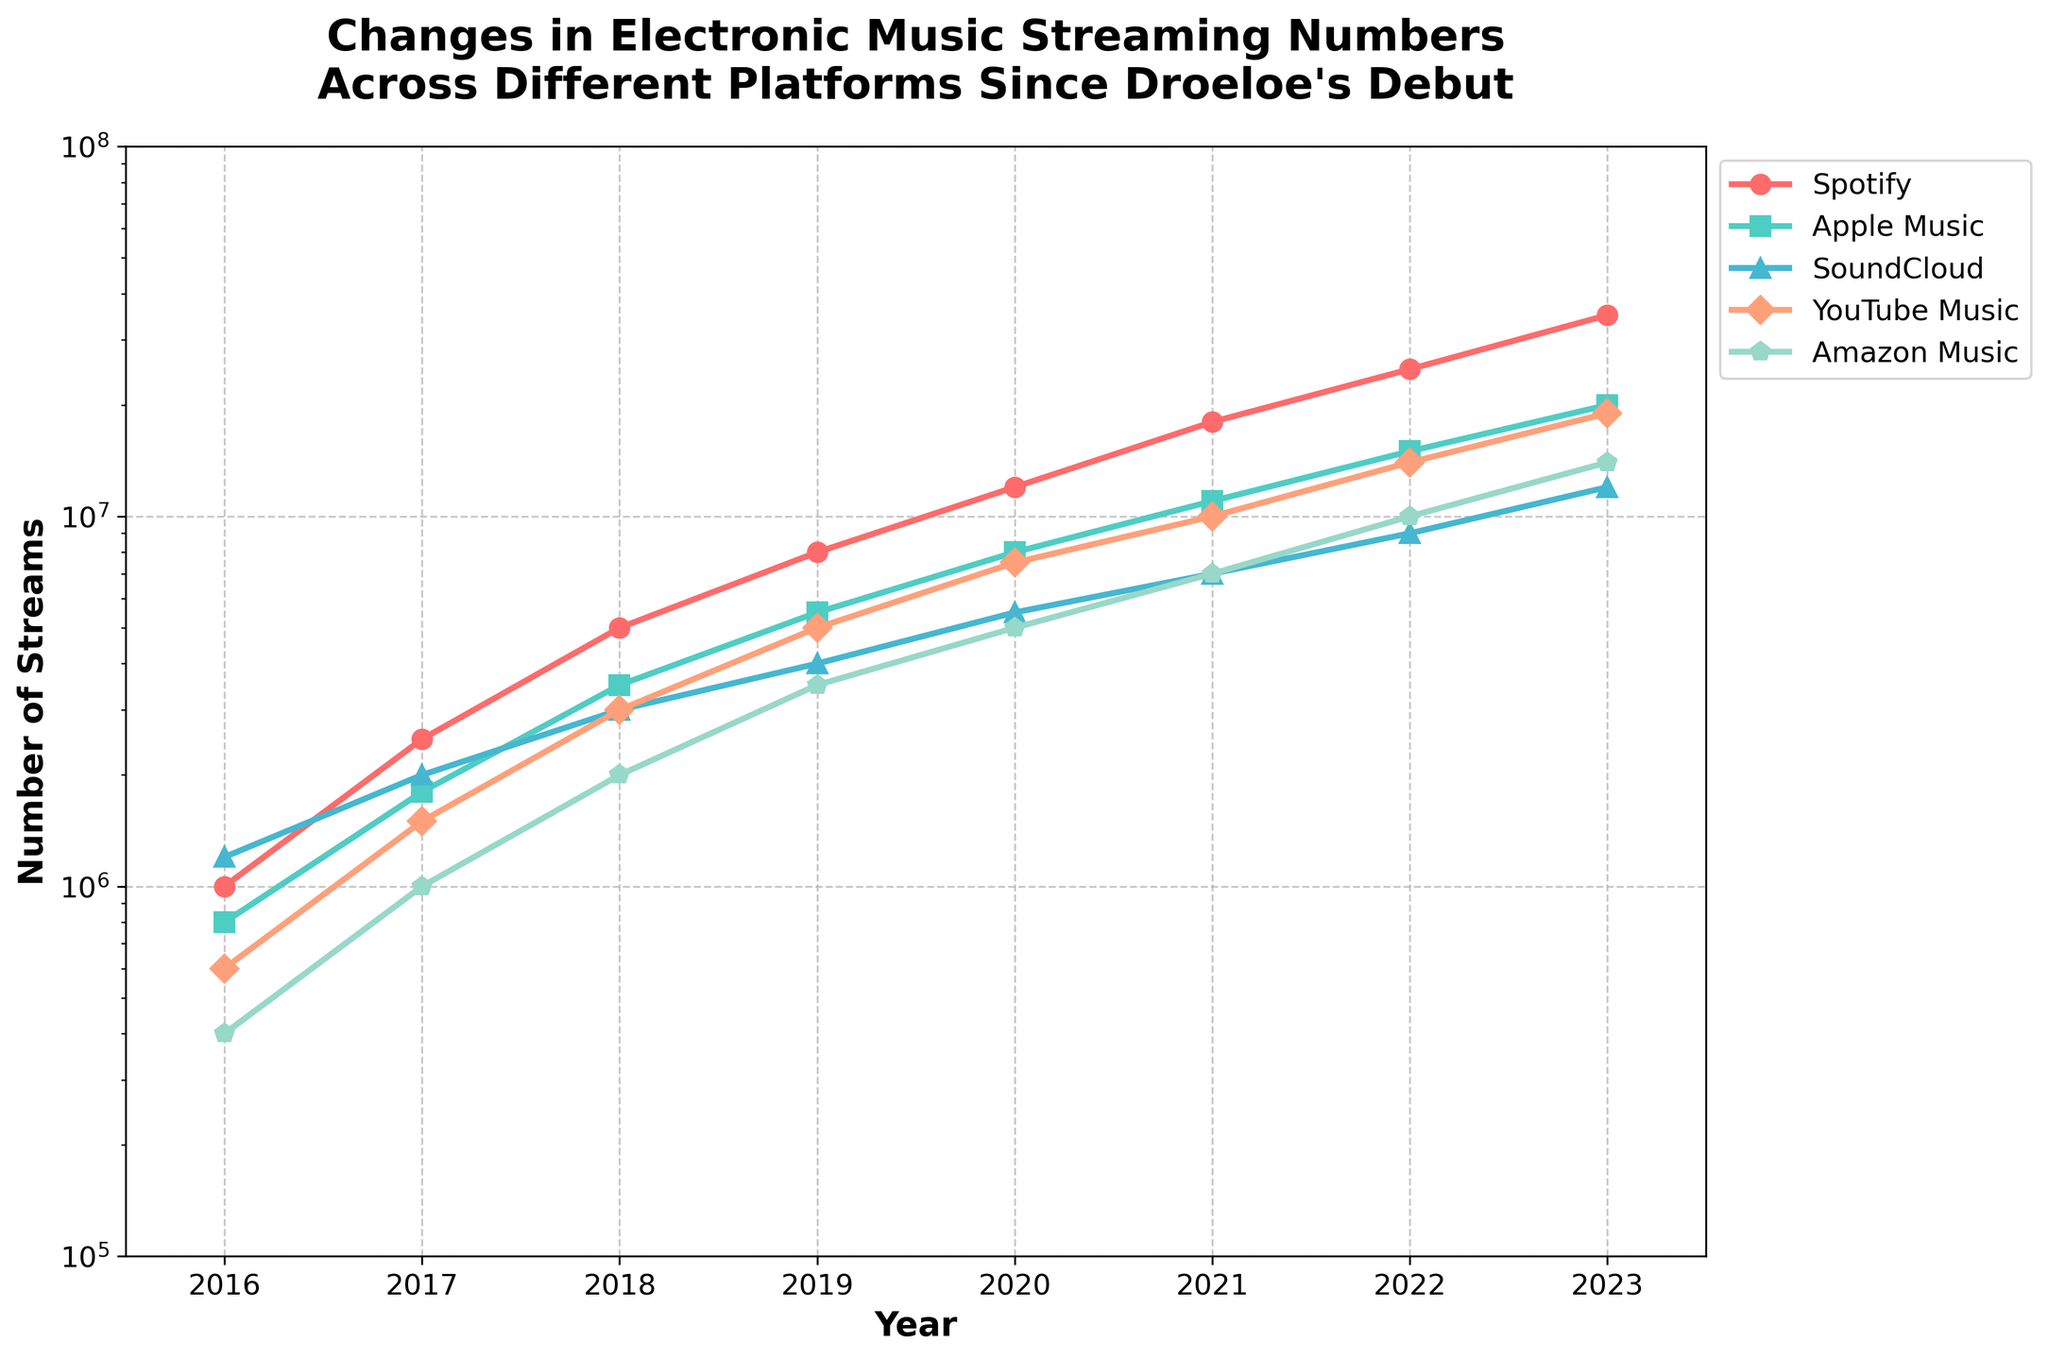What year did Spotify streams surpass 10 million? From the graph, identify when the line for Spotify crosses the 10 million mark. The intersection occurs in 2020.
Answer: 2020 Which platform had the least streams in 2016? Look at the beginning of each line for the year 2016 and compare the y-axis values. The lowest point corresponds to Amazon Music.
Answer: Amazon Music How many streaming platforms had more than 5 million streams in 2020? Check the y-axis values for each platform in 2020 and count how many exceed 5 million. Four platforms exceed this threshold: Spotify, Apple Music, YouTube Music, and Amazon Music.
Answer: 4 By how much did YouTube Music streams increase between 2019 and 2023? Compare the y-axis values for YouTube Music in 2019 (5 million) and 2023 (19 million) and find the difference: 19 million - 5 million.
Answer: 14 million Which platform experienced the most significant growth in streaming numbers from 2021 to 2022? Compare the slopes of the lines between 2021 and 2022 for all platforms: Spotify increased by 7 million, Apple Music by 4 million, SoundCloud by 2 million, YouTube Music by 4 million, and Amazon Music by 3 million. Spotify shows the highest increase.
Answer: Spotify What is the average number of streams for SoundCloud in the years 2020 and 2021? Add the streams for SoundCloud in 2020 (5.5 million) and 2021 (7 million) and divide by 2: (5.5 + 7)/2.
Answer: 6.25 million Which color line represents Apple Music? Identify the color of the line corresponding to Apple Music. The graph shows Apple Music in teal color.
Answer: teal In which year did all platforms collectively exceed 10 million streams? Check each year's combined total streams across all platforms and identify the first year exceeding 10 million. This happens in 2021 since from that year the total is well above 10 million.
Answer: 2021 By how much did Apple Music streams increase between 2016 and 2023? Compare the y-axis values for Apple Music in 2016 (800,000) and 2023 (20 million) and find the difference: 20 million - 0.8 million.
Answer: 19.2 million Which platform had the smallest increase in streaming numbers from 2018 to 2019? Compare the differences in streaming numbers for each platform between 2018 and 2019. SoundCloud increased by 1 million which is the smallest.
Answer: SoundCloud 